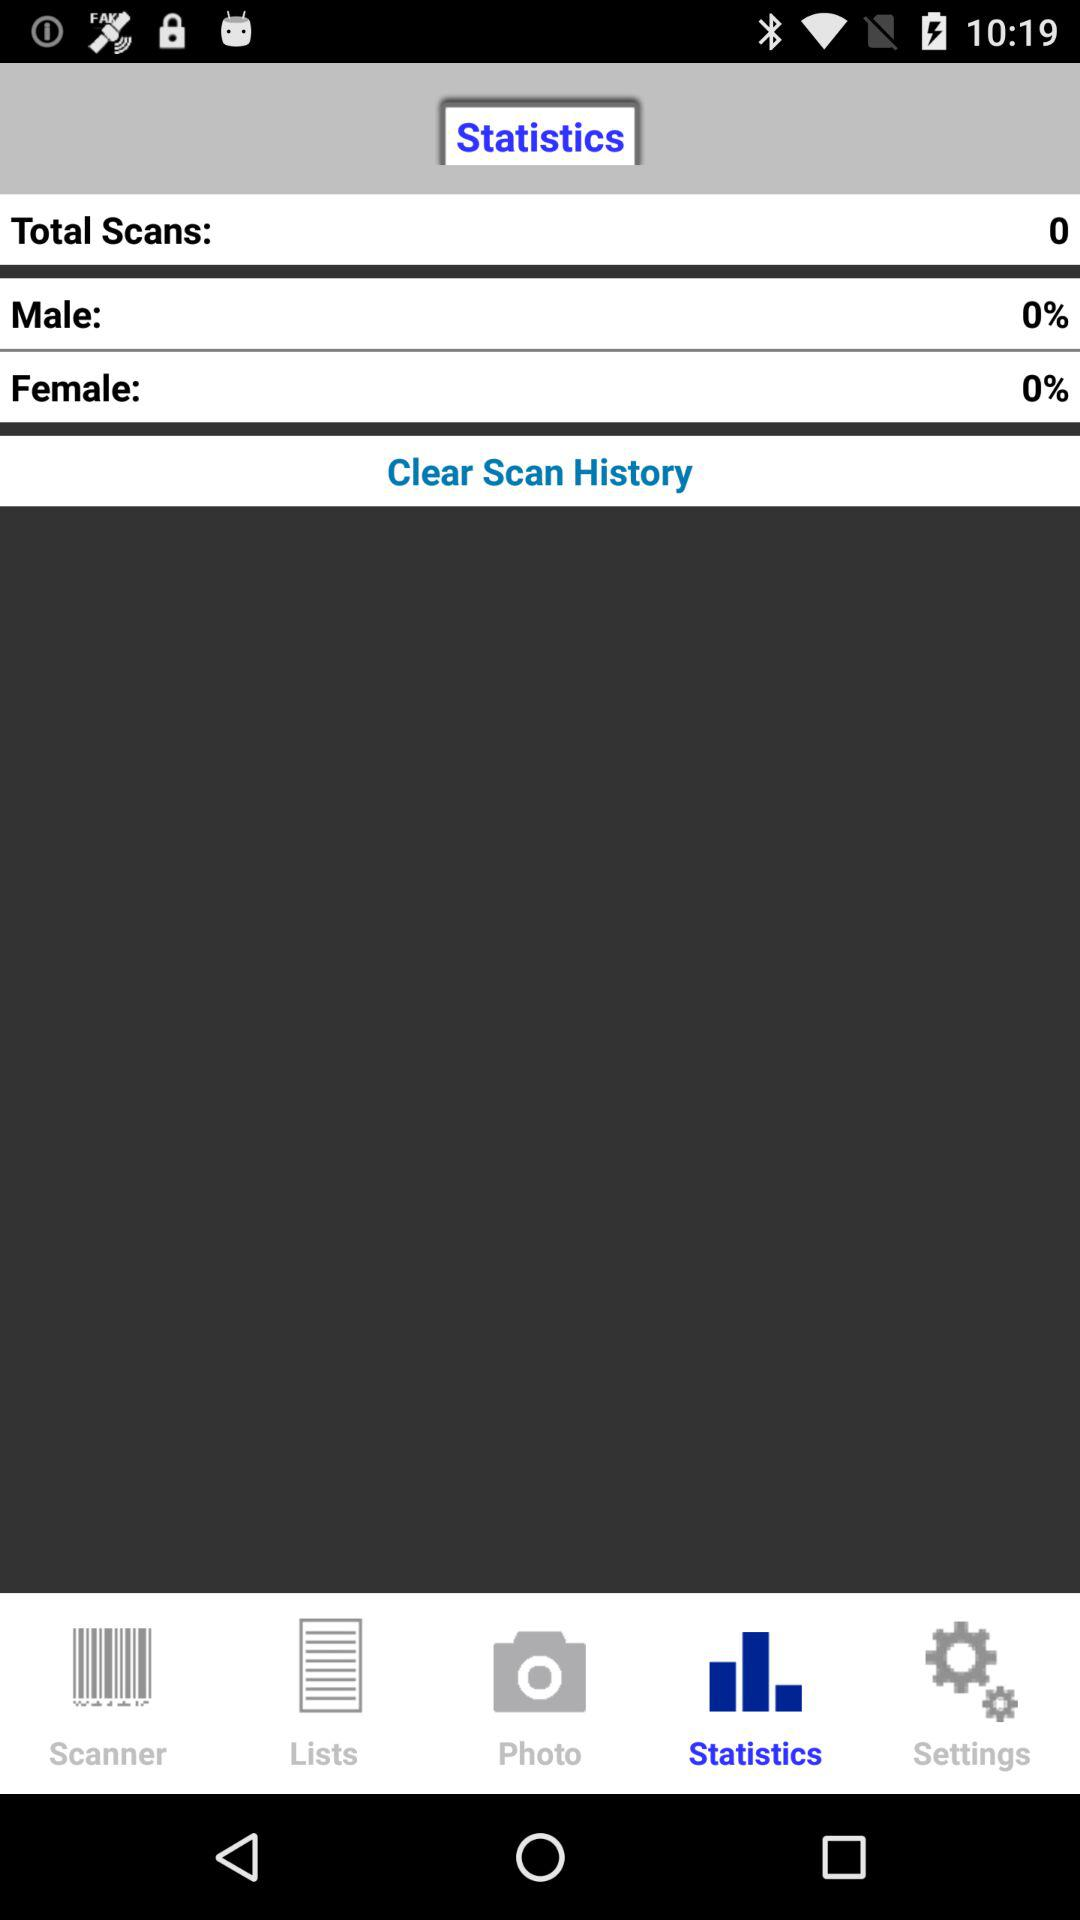What is the percentage of female? The percentage of female is 0. 